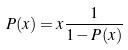Convert formula to latex. <formula><loc_0><loc_0><loc_500><loc_500>P ( x ) = x \frac { 1 } { 1 - P ( x ) }</formula> 